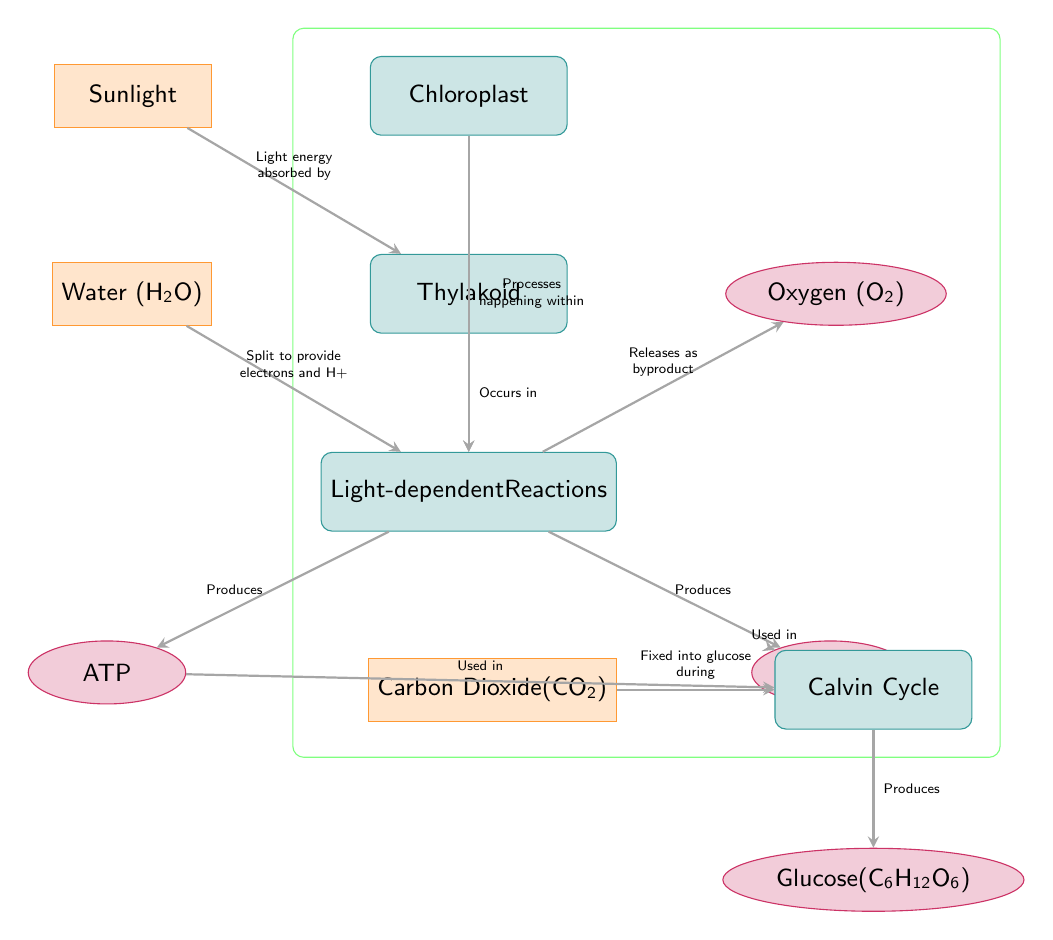What are the inputs for the photosynthesis process shown in the diagram? The diagram displays two inputs: Water (H₂O) and Carbon Dioxide (CO₂). These inputs are represented as input nodes leading to the light-dependent reactions and the Calvin Cycle respectively, highlighting their significance in the process of photosynthesis.
Answer: Water (H₂O), Carbon Dioxide (CO₂) What is the output of light-dependent reactions? The light-dependent reactions produce two outputs, ATP and NADPH, which are essential for the subsequent light-independent reactions. Both outputs are located below the light-dependent reactions node and are associated with the energy conversion processes that occur during this phase.
Answer: ATP, NADPH In which part of the chloroplast does the light-dependent reaction occur? The diagram indicates that the light-dependent reactions take place in the thylakoid. This is specified through an arrow drawn from the thylakoid node, showing its role and location within the chloroplast.
Answer: Thylakoid How many outputs are produced after the Calvin Cycle according to the diagram? The diagram shows that the Calvin Cycle produces one output, which is glucose (C₆H₁₂O₆). This is evident as there is a single output node directly connected to the Calvin Cycle, indicating the final product of the photosynthesis process.
Answer: Glucose (C₆H₁₂O₆) What is the role of sunlight in the photosynthesis process as shown in the diagram? Sunlight is described as providing light energy that is absorbed during the light-dependent reactions. The diagram illustrates this connection through an arrow that starts from the sunlight input node and points towards the thylakoid node, emphasizing its importance in energy transformation.
Answer: Absorbed by thylakoid What are the two products released by the light-dependent reactions? The light-dependent reactions release two byproducts: Oxygen (O₂), which is notably a waste product, and the energy carriers ATP and NADPH. The oxygen is specifically indicated as a byproduct, while ATP and NADPH are crucial for the next phase of photosynthesis, indicating their functional outputs.
Answer: Oxygen (O₂) Which cycle is responsible for producing glucose? The diagram specifies that the Calvin Cycle is responsible for producing glucose, evidenced by the arrow that connects the Calvin Cycle node to the glucose output node. This illustrates the final stage in the photosynthesis process where CO₂ is converted into glucose.
Answer: Calvin Cycle 